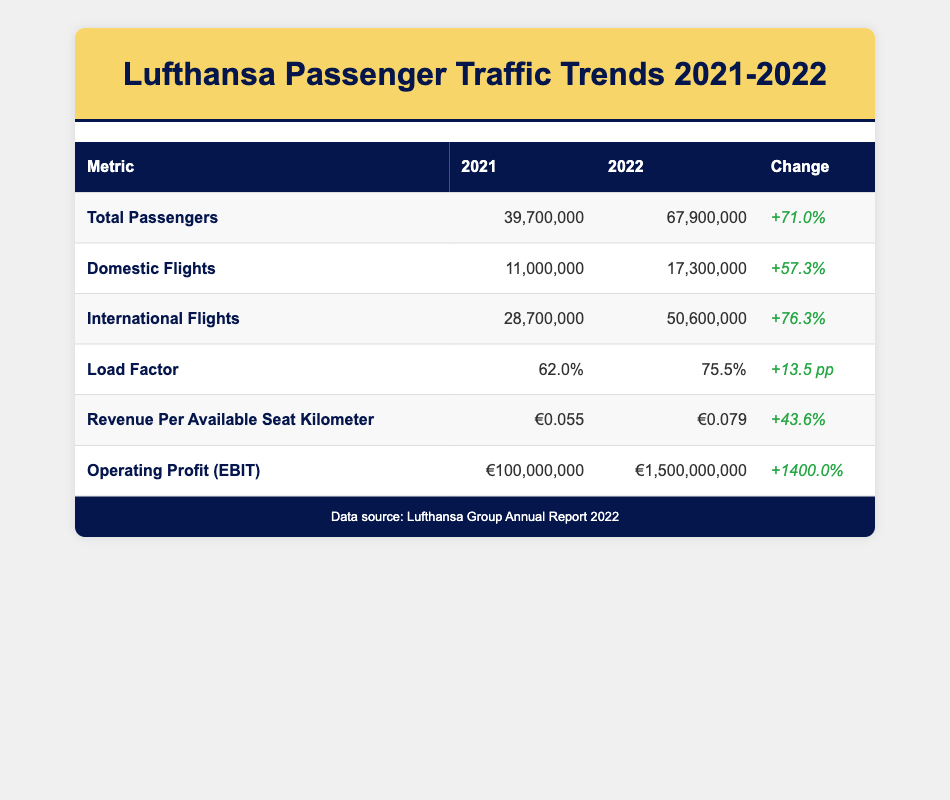What was the total number of passengers for Lufthansa in 2021? According to the table, the total number of passengers for Lufthansa in 2021 is listed directly under the "Total Passengers" row for that year. It states 39,700,000 passengers.
Answer: 39,700,000 What percentage increase in total passengers did Lufthansa experience from 2021 to 2022? The total number of passengers in 2021 was 39,700,000 and in 2022 it was 67,900,000. To find the percentage increase, we subtract the 2021 total from the 2022 total (67,900,000 - 39,700,000 = 28,200,000). Then, we divide the increase (28,200,000) by the 2021 figure (39,700,000) and multiply by 100 to convert to a percentage: (28,200,000 / 39,700,000) * 100 = 71.0%.
Answer: 71.0% Was there an increase in the load factor percentage from 2021 to 2022? The load factor percentage for 2021 is 62.0% and for 2022 it is 75.5%. Since 75.5% is greater than 62.0%, there was indeed an increase in the load factor percentage.
Answer: Yes What are the total revenue per available seat kilometer figures for 2021 and 2022? The table lists the revenue per available seat kilometer for 2021 as €0.055 and for 2022 as €0.079. This can be retrieved directly from the corresponding row in the table under that metric.
Answer: €0.055 for 2021 and €0.079 for 2022 What was the operating profit (EBIT) for Lufthansa in 2022 compared to 2021? The operating profit (EBIT) for 2021 was €100,000,000 and for 2022 it was €1,500,000,000. To find the difference, we subtract the 2021 profit from the 2022 profit (1,500,000,000 - 100,000,000 = 1,400,000,000). The profits significantly increased from 2021 to 2022.
Answer: €1,400,000,000 increase What is the total number of domestic flights in 2022 compared to international flights in the same year? In 2022, we have 17,300,000 domestic flights and 50,600,000 international flights. To compare, we can see that international flights far outnumber domestic flights. This gives insight into the travel patterns during that year.
Answer: International flights are significantly higher than domestic flights Did Lufthansa have a higher load factor percentage in 2022 than their operating profit in 2021? The load factor percentage in 2022 is 75.5% while the operating profit in 2021 is €100,000,000. The figures are in different categories (percentage vs currency) and are not directly comparable, but in terms of performance metrics, 75.5% is higher than many operational figures including the context of recovery post-pandemic.
Answer: Yes, in terms of performance metrics By how much did the total revenue per available seat kilometer increase between 2021 and 2022? The total revenue per available seat kilometer increased from €0.055 in 2021 to €0.079 in 2022. To find this increase, we subtract the 2021 figure from the 2022 figure: €0.079 - €0.055 = €0.024.
Answer: €0.024 increase 